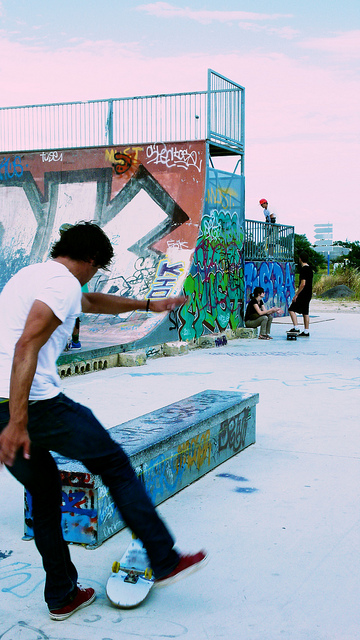What is the large ramp used for? A. football B. sledding C. basketball D. skateboarding The large ramp, adorned with vibrant graffiti and being actively used by a person riding a skateboard, is typically designed for skateboarding, which is option D. Skateboarding ramps like this one are used to perform tricks and maneuvers which require a smooth, inclined surface enabling skaters to gain air and execute various stunts. 